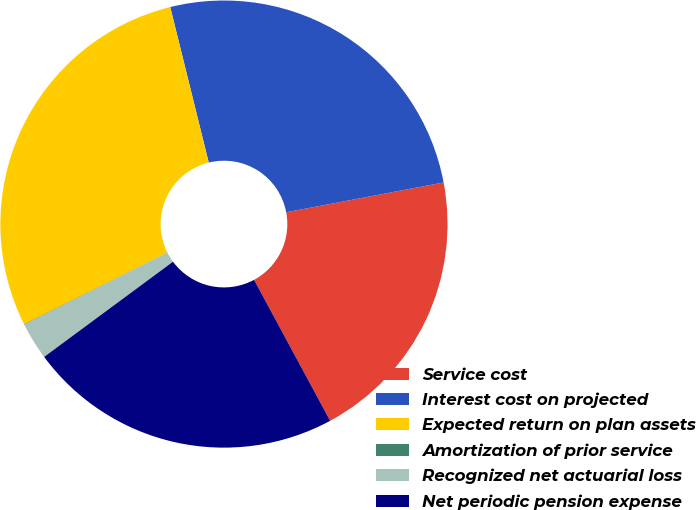Convert chart to OTSL. <chart><loc_0><loc_0><loc_500><loc_500><pie_chart><fcel>Service cost<fcel>Interest cost on projected<fcel>Expected return on plan assets<fcel>Amortization of prior service<fcel>Recognized net actuarial loss<fcel>Net periodic pension expense<nl><fcel>20.1%<fcel>25.88%<fcel>28.53%<fcel>0.04%<fcel>2.69%<fcel>22.75%<nl></chart> 